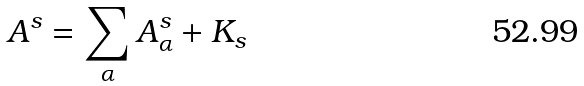Convert formula to latex. <formula><loc_0><loc_0><loc_500><loc_500>A ^ { s } = \sum _ { \alpha } A ^ { s } _ { \alpha } + K _ { s }</formula> 